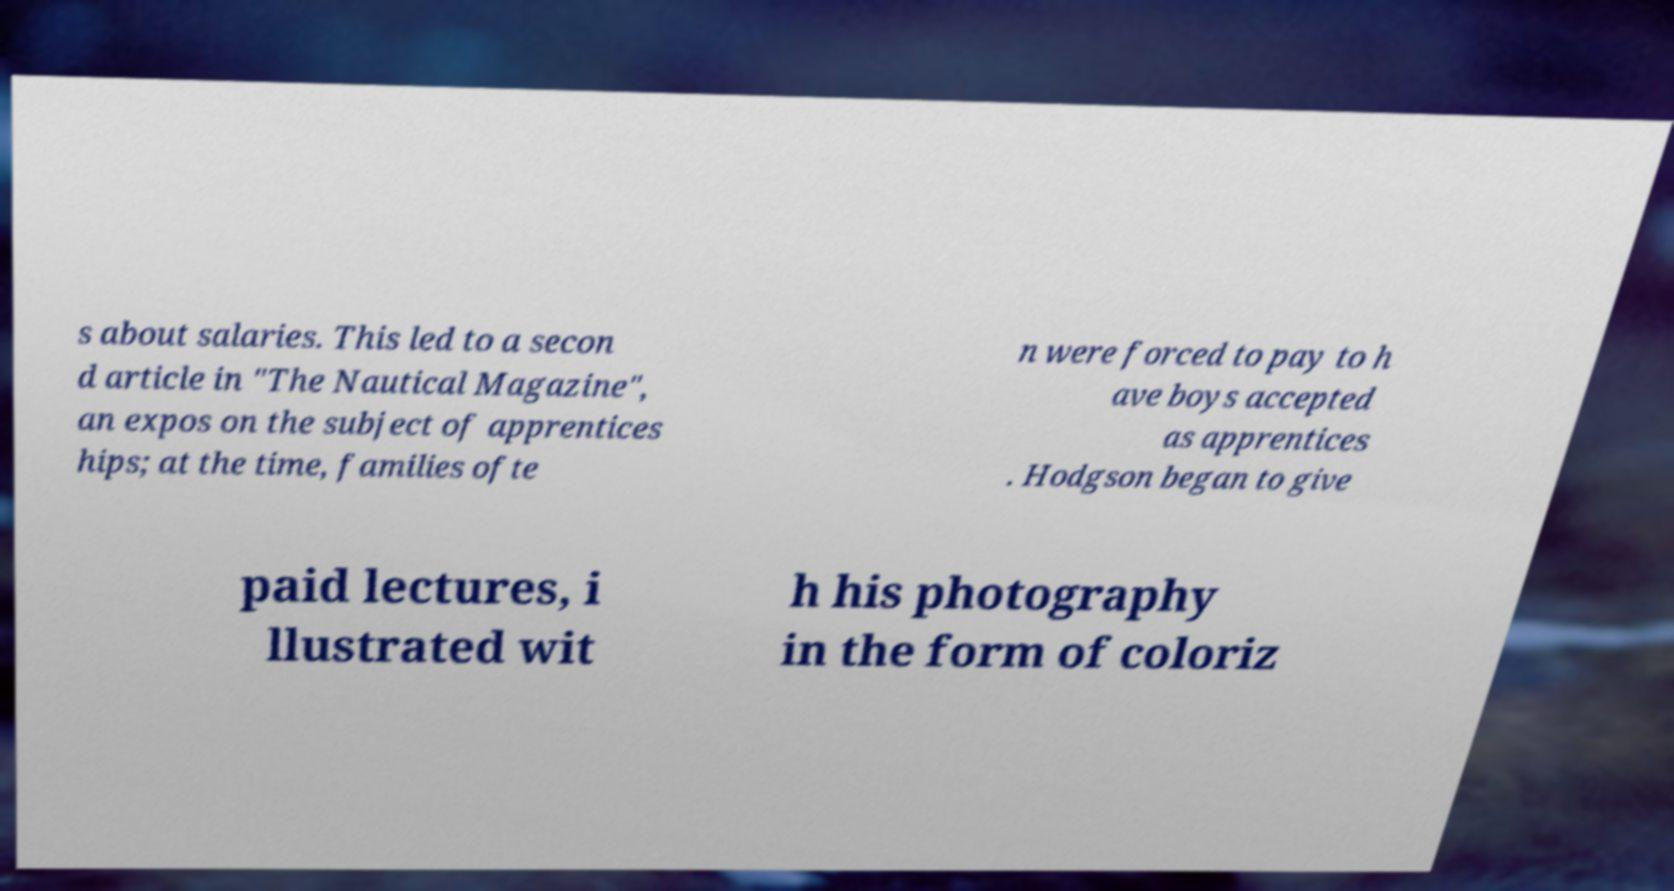Please read and relay the text visible in this image. What does it say? s about salaries. This led to a secon d article in "The Nautical Magazine", an expos on the subject of apprentices hips; at the time, families ofte n were forced to pay to h ave boys accepted as apprentices . Hodgson began to give paid lectures, i llustrated wit h his photography in the form of coloriz 